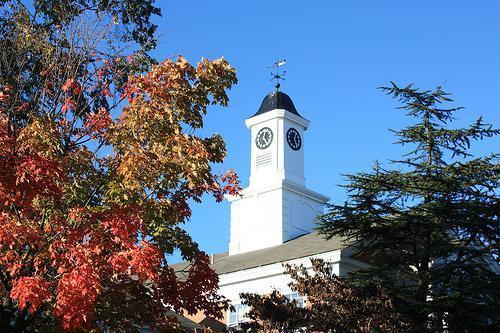How many clocks are visible?
Give a very brief answer. 2. 